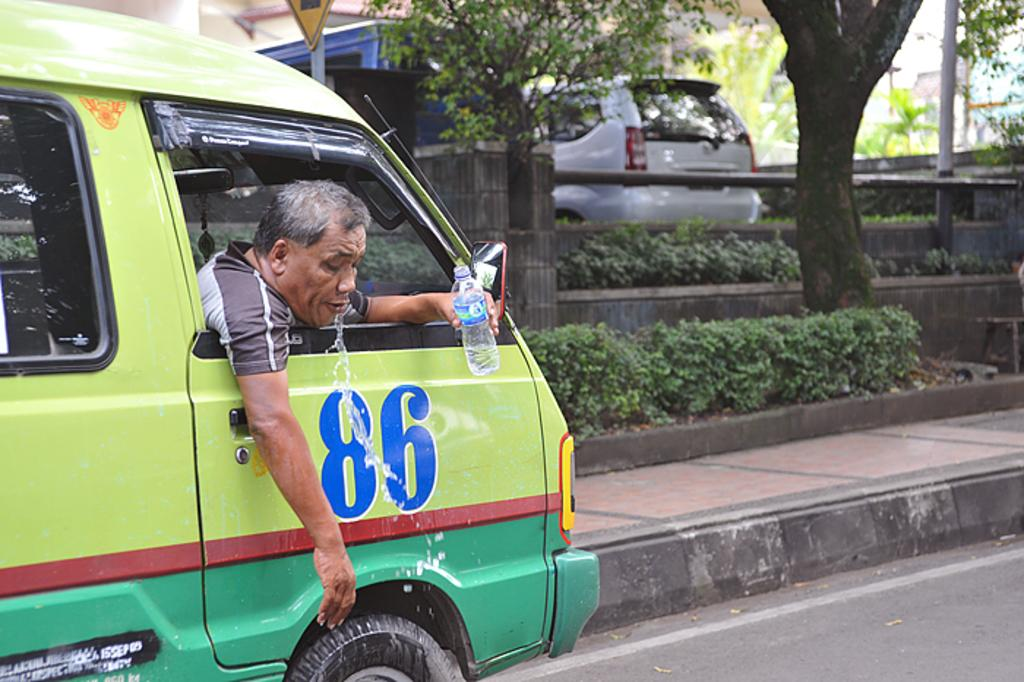What is the man in the image doing inside the vehicle? The man is holding a bottle in the image. What can be seen in the background of the image? The image shows a road, plants, a car, and a tree. What type of vehicle is the man inside? The facts do not specify the type of vehicle, but it is mentioned that there is a car in the image. Where is the desk located in the image? There is no desk present in the image. 